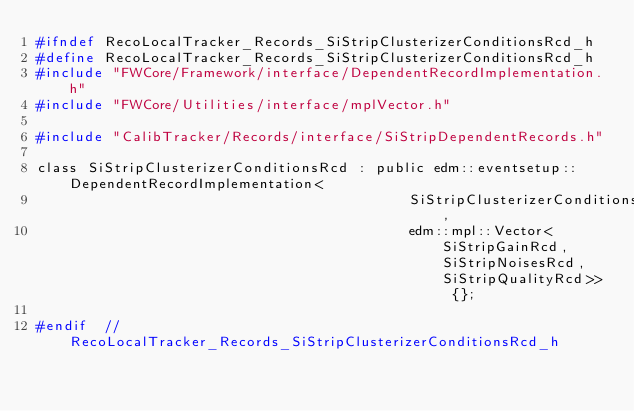<code> <loc_0><loc_0><loc_500><loc_500><_C_>#ifndef RecoLocalTracker_Records_SiStripClusterizerConditionsRcd_h
#define RecoLocalTracker_Records_SiStripClusterizerConditionsRcd_h
#include "FWCore/Framework/interface/DependentRecordImplementation.h"
#include "FWCore/Utilities/interface/mplVector.h"

#include "CalibTracker/Records/interface/SiStripDependentRecords.h"

class SiStripClusterizerConditionsRcd : public edm::eventsetup::DependentRecordImplementation<
                                            SiStripClusterizerConditionsRcd,
                                            edm::mpl::Vector<SiStripGainRcd, SiStripNoisesRcd, SiStripQualityRcd>> {};

#endif  // RecoLocalTracker_Records_SiStripClusterizerConditionsRcd_h
</code> 